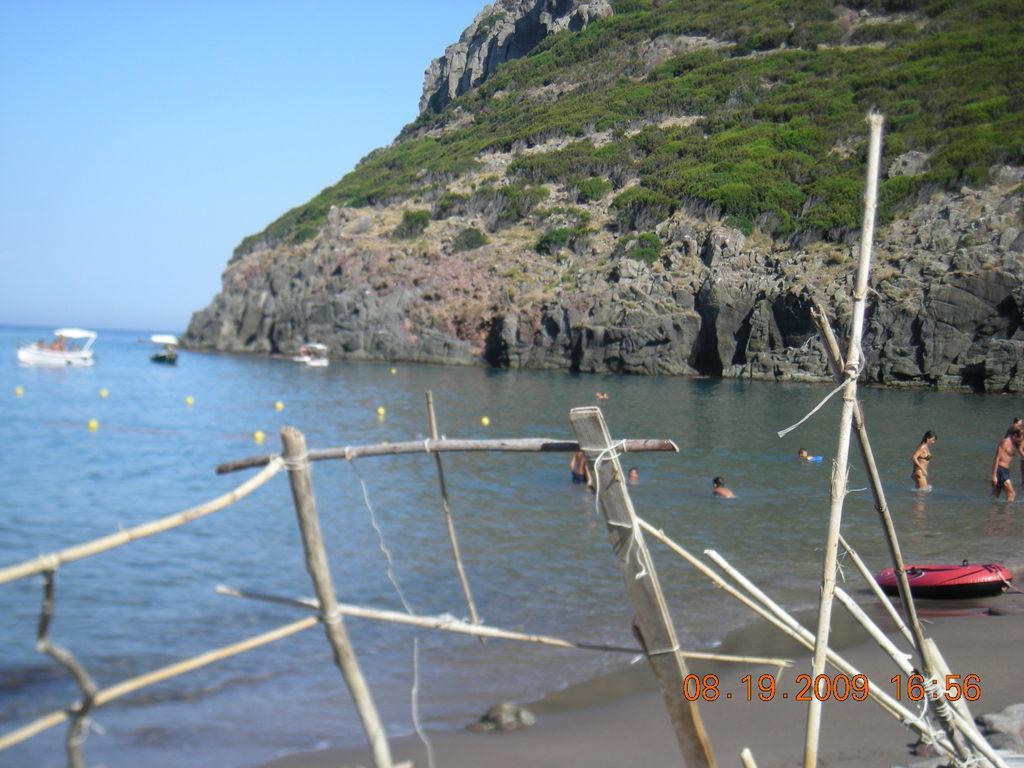Could you give a brief overview of what you see in this image? Here in this picture we can see water covered over the place and we can see boats present in it and we can see people swimming in the water and on the right side we can see mountains that are covered with grass and plants and in the front we can see railing present and we can see the sky is clear. 